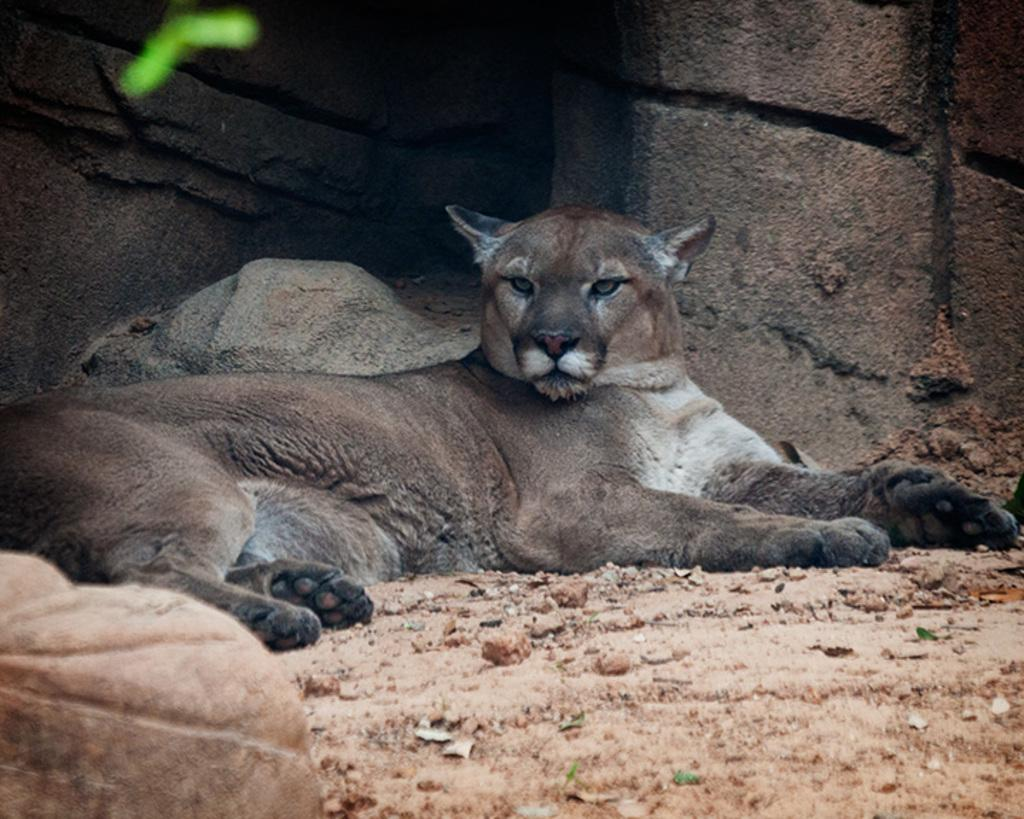What is present in the image? There is an animal in the image. What is the animal doing in the image? The animal is sleeping on the ground. What can be seen on the right side of the image? There is a concrete wall on the right side of the image. How many legs does the nation have in the image? There is no nation present in the image, and therefore no legs can be attributed to it. 